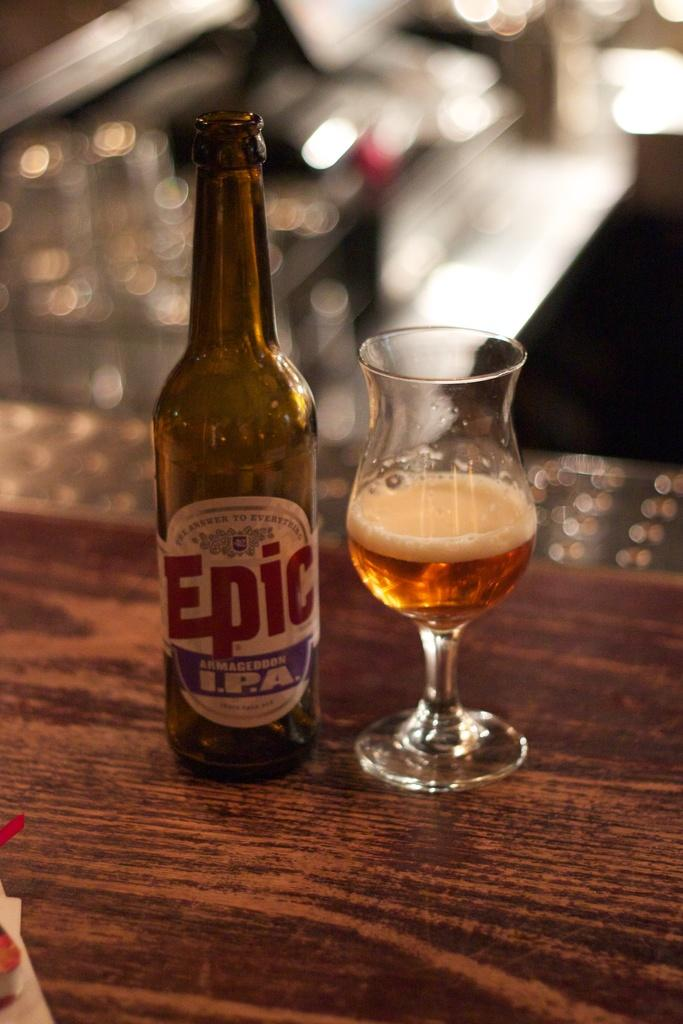Provide a one-sentence caption for the provided image. A bottle of Epic I.P.A. is on a wooden surface next to a glass. 